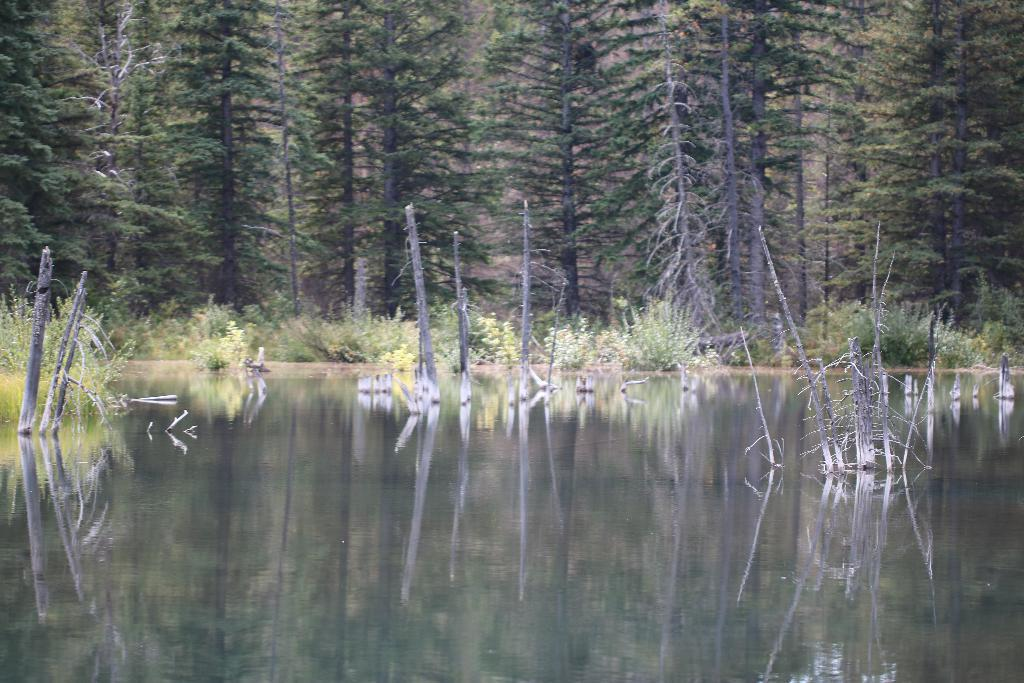What type of natural elements can be seen in the image? There are many trees and plants in the image. What man-made structures are present in the image? There are poles in the image. What is visible at the bottom of the image? There is water visible at the bottom of the image. What can be observed on the surface of the water? There are reflections on the water. What type of animal can be seen in the image? There are no animals visible in the image. 